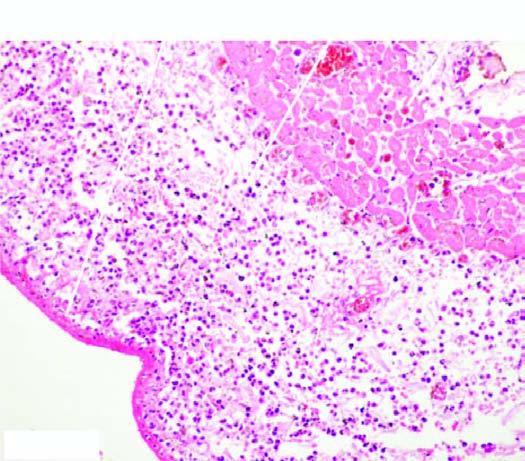what is the pericardium covered with?
Answer the question using a single word or phrase. Pink serofibrinous 